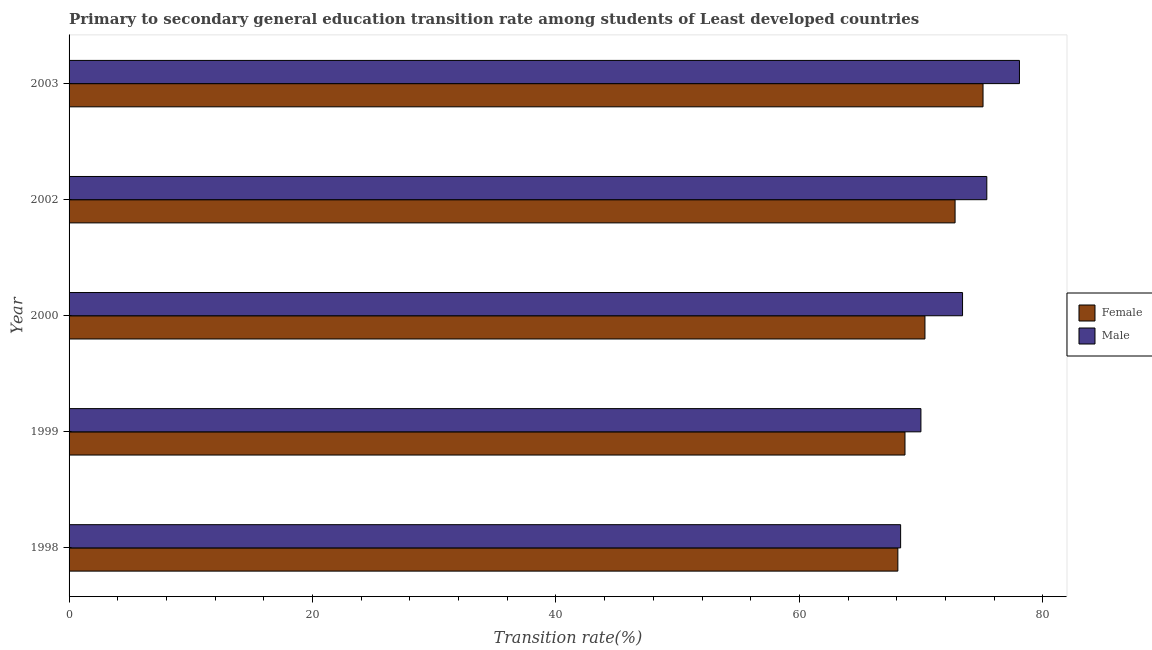How many different coloured bars are there?
Your answer should be very brief. 2. How many bars are there on the 2nd tick from the top?
Ensure brevity in your answer.  2. How many bars are there on the 5th tick from the bottom?
Provide a short and direct response. 2. What is the transition rate among male students in 2002?
Your response must be concise. 75.39. Across all years, what is the maximum transition rate among male students?
Give a very brief answer. 78.08. Across all years, what is the minimum transition rate among female students?
Your answer should be very brief. 68.09. In which year was the transition rate among female students minimum?
Ensure brevity in your answer.  1998. What is the total transition rate among female students in the graph?
Keep it short and to the point. 354.94. What is the difference between the transition rate among male students in 2000 and that in 2003?
Offer a terse response. -4.67. What is the difference between the transition rate among female students in 2000 and the transition rate among male students in 2003?
Ensure brevity in your answer.  -7.76. What is the average transition rate among female students per year?
Your response must be concise. 70.99. In the year 2002, what is the difference between the transition rate among female students and transition rate among male students?
Your answer should be compact. -2.61. In how many years, is the transition rate among female students greater than 24 %?
Offer a terse response. 5. What is the ratio of the transition rate among female students in 2000 to that in 2003?
Your response must be concise. 0.94. Is the transition rate among male students in 2002 less than that in 2003?
Your answer should be compact. Yes. What is the difference between the highest and the second highest transition rate among male students?
Your answer should be compact. 2.68. What is the difference between the highest and the lowest transition rate among female students?
Offer a very short reply. 7. What does the 1st bar from the top in 1999 represents?
Offer a terse response. Male. What does the 1st bar from the bottom in 1998 represents?
Ensure brevity in your answer.  Female. Are the values on the major ticks of X-axis written in scientific E-notation?
Provide a short and direct response. No. Does the graph contain grids?
Keep it short and to the point. No. How are the legend labels stacked?
Provide a succinct answer. Vertical. What is the title of the graph?
Ensure brevity in your answer.  Primary to secondary general education transition rate among students of Least developed countries. What is the label or title of the X-axis?
Your answer should be very brief. Transition rate(%). What is the label or title of the Y-axis?
Ensure brevity in your answer.  Year. What is the Transition rate(%) in Female in 1998?
Your answer should be very brief. 68.09. What is the Transition rate(%) in Male in 1998?
Offer a very short reply. 68.31. What is the Transition rate(%) of Female in 1999?
Make the answer very short. 68.67. What is the Transition rate(%) of Male in 1999?
Your answer should be very brief. 69.98. What is the Transition rate(%) of Female in 2000?
Your response must be concise. 70.31. What is the Transition rate(%) in Male in 2000?
Your answer should be very brief. 73.4. What is the Transition rate(%) of Female in 2002?
Make the answer very short. 72.79. What is the Transition rate(%) in Male in 2002?
Offer a very short reply. 75.39. What is the Transition rate(%) of Female in 2003?
Offer a very short reply. 75.08. What is the Transition rate(%) of Male in 2003?
Provide a succinct answer. 78.08. Across all years, what is the maximum Transition rate(%) in Female?
Offer a very short reply. 75.08. Across all years, what is the maximum Transition rate(%) in Male?
Offer a very short reply. 78.08. Across all years, what is the minimum Transition rate(%) of Female?
Offer a very short reply. 68.09. Across all years, what is the minimum Transition rate(%) in Male?
Keep it short and to the point. 68.31. What is the total Transition rate(%) in Female in the graph?
Give a very brief answer. 354.94. What is the total Transition rate(%) of Male in the graph?
Provide a succinct answer. 365.16. What is the difference between the Transition rate(%) of Female in 1998 and that in 1999?
Your response must be concise. -0.59. What is the difference between the Transition rate(%) of Male in 1998 and that in 1999?
Your answer should be very brief. -1.67. What is the difference between the Transition rate(%) in Female in 1998 and that in 2000?
Ensure brevity in your answer.  -2.23. What is the difference between the Transition rate(%) of Male in 1998 and that in 2000?
Give a very brief answer. -5.09. What is the difference between the Transition rate(%) in Female in 1998 and that in 2002?
Ensure brevity in your answer.  -4.7. What is the difference between the Transition rate(%) in Male in 1998 and that in 2002?
Make the answer very short. -7.08. What is the difference between the Transition rate(%) of Female in 1998 and that in 2003?
Keep it short and to the point. -7. What is the difference between the Transition rate(%) of Male in 1998 and that in 2003?
Your response must be concise. -9.76. What is the difference between the Transition rate(%) in Female in 1999 and that in 2000?
Keep it short and to the point. -1.64. What is the difference between the Transition rate(%) in Male in 1999 and that in 2000?
Offer a terse response. -3.42. What is the difference between the Transition rate(%) of Female in 1999 and that in 2002?
Offer a terse response. -4.12. What is the difference between the Transition rate(%) of Male in 1999 and that in 2002?
Your answer should be very brief. -5.41. What is the difference between the Transition rate(%) in Female in 1999 and that in 2003?
Ensure brevity in your answer.  -6.41. What is the difference between the Transition rate(%) of Male in 1999 and that in 2003?
Your response must be concise. -8.1. What is the difference between the Transition rate(%) in Female in 2000 and that in 2002?
Keep it short and to the point. -2.48. What is the difference between the Transition rate(%) of Male in 2000 and that in 2002?
Offer a very short reply. -1.99. What is the difference between the Transition rate(%) in Female in 2000 and that in 2003?
Offer a very short reply. -4.77. What is the difference between the Transition rate(%) in Male in 2000 and that in 2003?
Provide a short and direct response. -4.68. What is the difference between the Transition rate(%) of Female in 2002 and that in 2003?
Provide a short and direct response. -2.3. What is the difference between the Transition rate(%) of Male in 2002 and that in 2003?
Provide a succinct answer. -2.68. What is the difference between the Transition rate(%) in Female in 1998 and the Transition rate(%) in Male in 1999?
Your response must be concise. -1.89. What is the difference between the Transition rate(%) in Female in 1998 and the Transition rate(%) in Male in 2000?
Your answer should be compact. -5.31. What is the difference between the Transition rate(%) in Female in 1998 and the Transition rate(%) in Male in 2002?
Ensure brevity in your answer.  -7.31. What is the difference between the Transition rate(%) of Female in 1998 and the Transition rate(%) of Male in 2003?
Provide a succinct answer. -9.99. What is the difference between the Transition rate(%) in Female in 1999 and the Transition rate(%) in Male in 2000?
Offer a terse response. -4.73. What is the difference between the Transition rate(%) of Female in 1999 and the Transition rate(%) of Male in 2002?
Make the answer very short. -6.72. What is the difference between the Transition rate(%) of Female in 1999 and the Transition rate(%) of Male in 2003?
Your answer should be very brief. -9.4. What is the difference between the Transition rate(%) in Female in 2000 and the Transition rate(%) in Male in 2002?
Make the answer very short. -5.08. What is the difference between the Transition rate(%) of Female in 2000 and the Transition rate(%) of Male in 2003?
Your answer should be very brief. -7.76. What is the difference between the Transition rate(%) in Female in 2002 and the Transition rate(%) in Male in 2003?
Provide a short and direct response. -5.29. What is the average Transition rate(%) of Female per year?
Make the answer very short. 70.99. What is the average Transition rate(%) in Male per year?
Provide a short and direct response. 73.03. In the year 1998, what is the difference between the Transition rate(%) of Female and Transition rate(%) of Male?
Your answer should be compact. -0.23. In the year 1999, what is the difference between the Transition rate(%) of Female and Transition rate(%) of Male?
Your answer should be compact. -1.31. In the year 2000, what is the difference between the Transition rate(%) in Female and Transition rate(%) in Male?
Offer a terse response. -3.09. In the year 2002, what is the difference between the Transition rate(%) in Female and Transition rate(%) in Male?
Your answer should be very brief. -2.61. In the year 2003, what is the difference between the Transition rate(%) of Female and Transition rate(%) of Male?
Offer a very short reply. -2.99. What is the ratio of the Transition rate(%) of Female in 1998 to that in 1999?
Your answer should be compact. 0.99. What is the ratio of the Transition rate(%) in Male in 1998 to that in 1999?
Your answer should be very brief. 0.98. What is the ratio of the Transition rate(%) of Female in 1998 to that in 2000?
Provide a succinct answer. 0.97. What is the ratio of the Transition rate(%) in Male in 1998 to that in 2000?
Keep it short and to the point. 0.93. What is the ratio of the Transition rate(%) in Female in 1998 to that in 2002?
Offer a terse response. 0.94. What is the ratio of the Transition rate(%) of Male in 1998 to that in 2002?
Make the answer very short. 0.91. What is the ratio of the Transition rate(%) in Female in 1998 to that in 2003?
Your answer should be very brief. 0.91. What is the ratio of the Transition rate(%) in Female in 1999 to that in 2000?
Ensure brevity in your answer.  0.98. What is the ratio of the Transition rate(%) of Male in 1999 to that in 2000?
Give a very brief answer. 0.95. What is the ratio of the Transition rate(%) in Female in 1999 to that in 2002?
Ensure brevity in your answer.  0.94. What is the ratio of the Transition rate(%) of Male in 1999 to that in 2002?
Offer a very short reply. 0.93. What is the ratio of the Transition rate(%) in Female in 1999 to that in 2003?
Provide a succinct answer. 0.91. What is the ratio of the Transition rate(%) of Male in 1999 to that in 2003?
Offer a very short reply. 0.9. What is the ratio of the Transition rate(%) in Female in 2000 to that in 2002?
Provide a short and direct response. 0.97. What is the ratio of the Transition rate(%) of Male in 2000 to that in 2002?
Ensure brevity in your answer.  0.97. What is the ratio of the Transition rate(%) of Female in 2000 to that in 2003?
Your response must be concise. 0.94. What is the ratio of the Transition rate(%) of Male in 2000 to that in 2003?
Your answer should be very brief. 0.94. What is the ratio of the Transition rate(%) in Female in 2002 to that in 2003?
Your answer should be compact. 0.97. What is the ratio of the Transition rate(%) of Male in 2002 to that in 2003?
Make the answer very short. 0.97. What is the difference between the highest and the second highest Transition rate(%) of Female?
Provide a short and direct response. 2.3. What is the difference between the highest and the second highest Transition rate(%) of Male?
Your answer should be very brief. 2.68. What is the difference between the highest and the lowest Transition rate(%) in Female?
Keep it short and to the point. 7. What is the difference between the highest and the lowest Transition rate(%) of Male?
Provide a short and direct response. 9.76. 